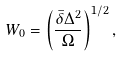Convert formula to latex. <formula><loc_0><loc_0><loc_500><loc_500>W _ { 0 } = \left ( \frac { \bar { \delta } \Delta ^ { 2 } } { \Omega } \right ) ^ { 1 / 2 } ,</formula> 